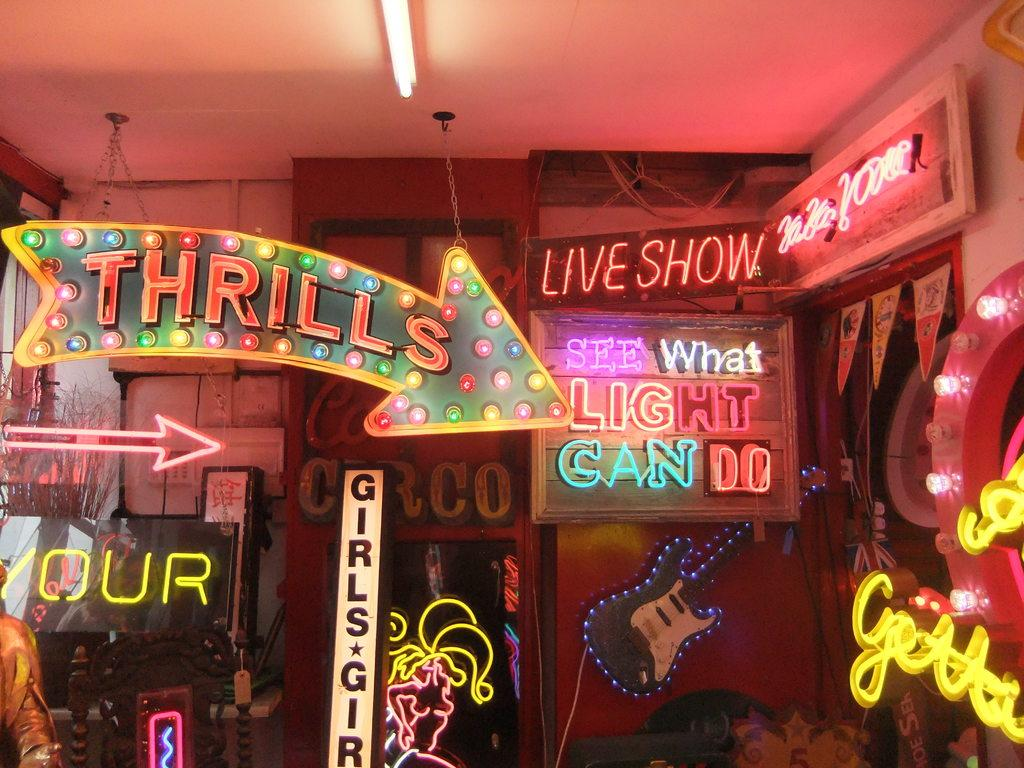What can be seen written on the wall in the image? There are names on the wall in the image. What type of lighting is present in the image? There is a tube light on the ceiling in the image. How many geese are present in the image? There are no geese present in the image. What territory does the image depict? The image does not depict any specific territory. 